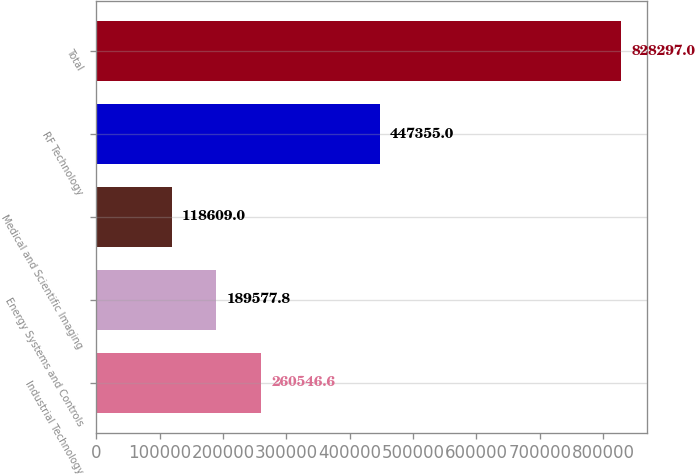Convert chart to OTSL. <chart><loc_0><loc_0><loc_500><loc_500><bar_chart><fcel>Industrial Technology<fcel>Energy Systems and Controls<fcel>Medical and Scientific Imaging<fcel>RF Technology<fcel>Total<nl><fcel>260547<fcel>189578<fcel>118609<fcel>447355<fcel>828297<nl></chart> 